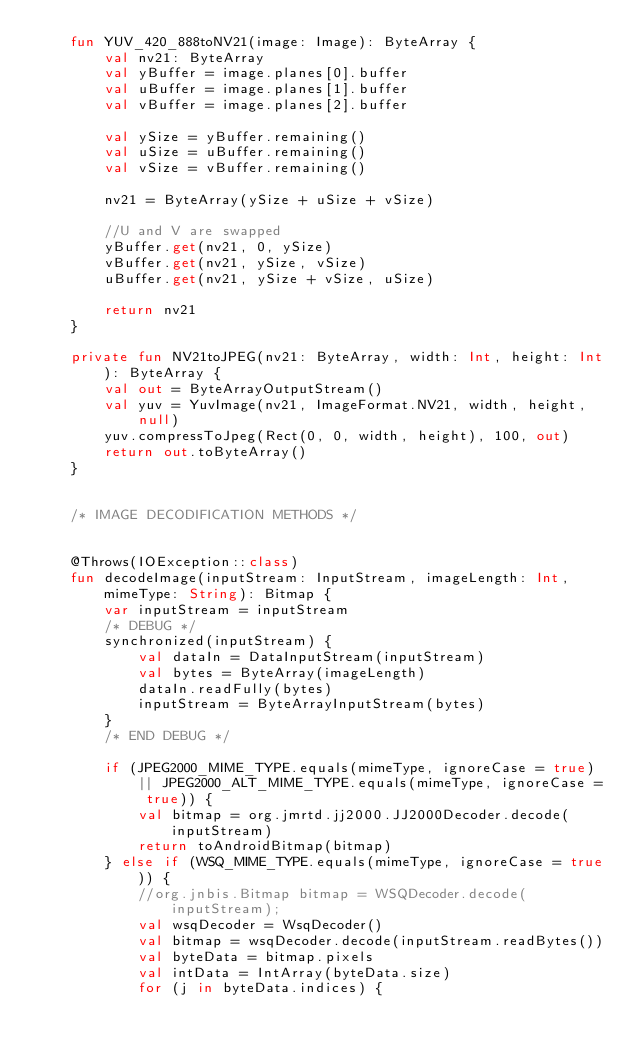Convert code to text. <code><loc_0><loc_0><loc_500><loc_500><_Kotlin_>    fun YUV_420_888toNV21(image: Image): ByteArray {
        val nv21: ByteArray
        val yBuffer = image.planes[0].buffer
        val uBuffer = image.planes[1].buffer
        val vBuffer = image.planes[2].buffer

        val ySize = yBuffer.remaining()
        val uSize = uBuffer.remaining()
        val vSize = vBuffer.remaining()

        nv21 = ByteArray(ySize + uSize + vSize)

        //U and V are swapped
        yBuffer.get(nv21, 0, ySize)
        vBuffer.get(nv21, ySize, vSize)
        uBuffer.get(nv21, ySize + vSize, uSize)

        return nv21
    }

    private fun NV21toJPEG(nv21: ByteArray, width: Int, height: Int): ByteArray {
        val out = ByteArrayOutputStream()
        val yuv = YuvImage(nv21, ImageFormat.NV21, width, height, null)
        yuv.compressToJpeg(Rect(0, 0, width, height), 100, out)
        return out.toByteArray()
    }


    /* IMAGE DECODIFICATION METHODS */


    @Throws(IOException::class)
    fun decodeImage(inputStream: InputStream, imageLength: Int, mimeType: String): Bitmap {
        var inputStream = inputStream
        /* DEBUG */
        synchronized(inputStream) {
            val dataIn = DataInputStream(inputStream)
            val bytes = ByteArray(imageLength)
            dataIn.readFully(bytes)
            inputStream = ByteArrayInputStream(bytes)
        }
        /* END DEBUG */

        if (JPEG2000_MIME_TYPE.equals(mimeType, ignoreCase = true) || JPEG2000_ALT_MIME_TYPE.equals(mimeType, ignoreCase = true)) {
            val bitmap = org.jmrtd.jj2000.JJ2000Decoder.decode(inputStream)
            return toAndroidBitmap(bitmap)
        } else if (WSQ_MIME_TYPE.equals(mimeType, ignoreCase = true)) {
            //org.jnbis.Bitmap bitmap = WSQDecoder.decode(inputStream);
            val wsqDecoder = WsqDecoder()
            val bitmap = wsqDecoder.decode(inputStream.readBytes())
            val byteData = bitmap.pixels
            val intData = IntArray(byteData.size)
            for (j in byteData.indices) {</code> 